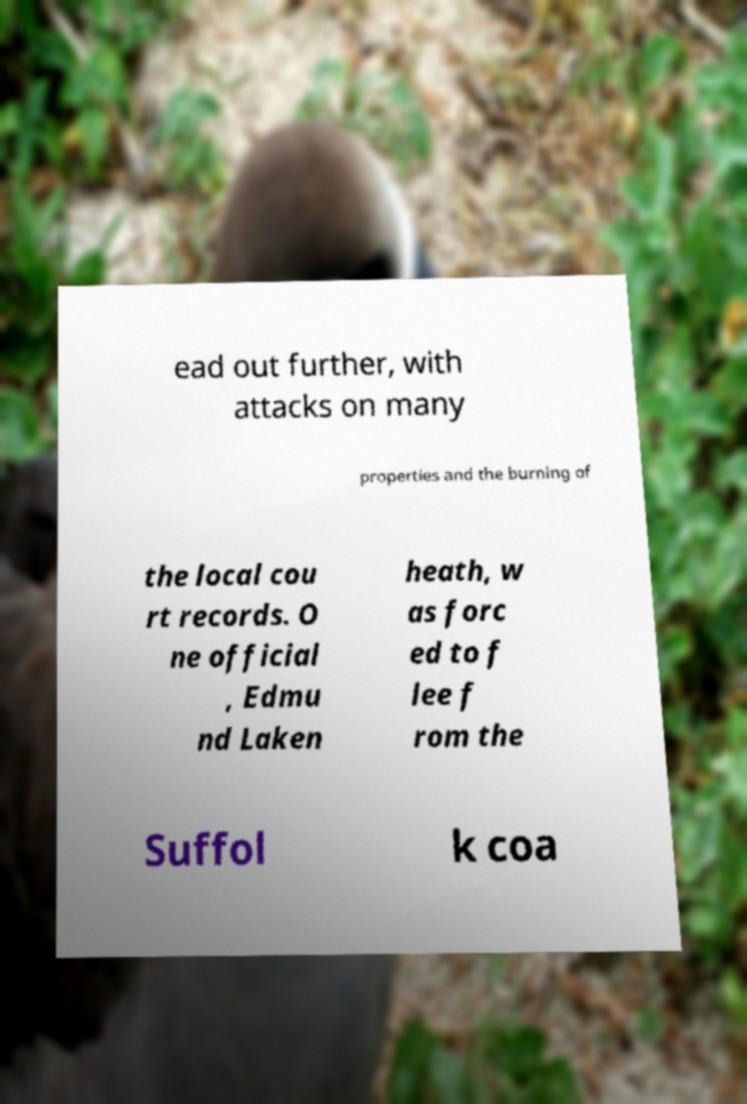I need the written content from this picture converted into text. Can you do that? ead out further, with attacks on many properties and the burning of the local cou rt records. O ne official , Edmu nd Laken heath, w as forc ed to f lee f rom the Suffol k coa 